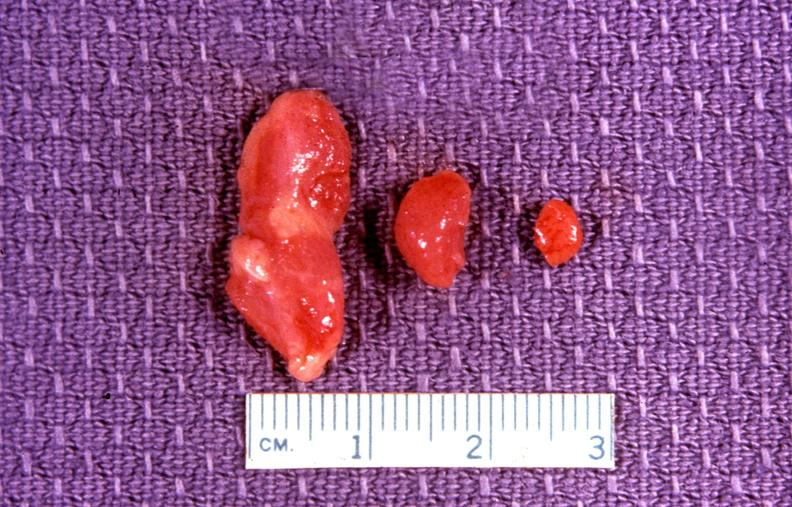s endocrine present?
Answer the question using a single word or phrase. Yes 